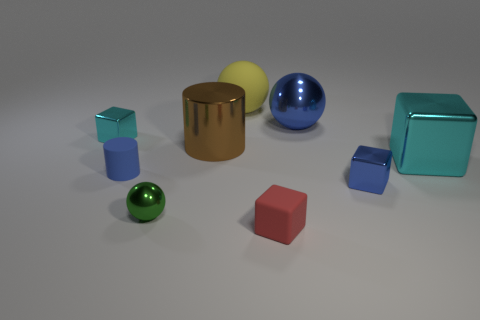Is the shape of the yellow matte thing the same as the small thing that is behind the big shiny cube?
Offer a terse response. No. Do the cyan thing to the left of the blue ball and the blue object left of the big blue thing have the same size?
Keep it short and to the point. Yes. Is there a tiny blue metallic thing behind the blue metallic object that is in front of the shiny ball to the right of the green metal object?
Ensure brevity in your answer.  No. Is the number of tiny cyan objects that are in front of the green metal sphere less than the number of large brown metal cylinders that are in front of the blue matte cylinder?
Provide a succinct answer. No. What shape is the tiny cyan object that is made of the same material as the tiny ball?
Ensure brevity in your answer.  Cube. There is a blue object that is to the left of the big ball behind the blue ball that is behind the small cyan metal object; how big is it?
Your response must be concise. Small. Is the number of big brown shiny cubes greater than the number of blue cylinders?
Offer a very short reply. No. There is a block that is behind the big metallic block; does it have the same color as the small rubber thing that is in front of the blue metallic block?
Offer a very short reply. No. Is the blue object behind the small cyan shiny block made of the same material as the cyan cube that is on the left side of the yellow thing?
Give a very brief answer. Yes. What number of metal things are the same size as the green ball?
Offer a very short reply. 2. 